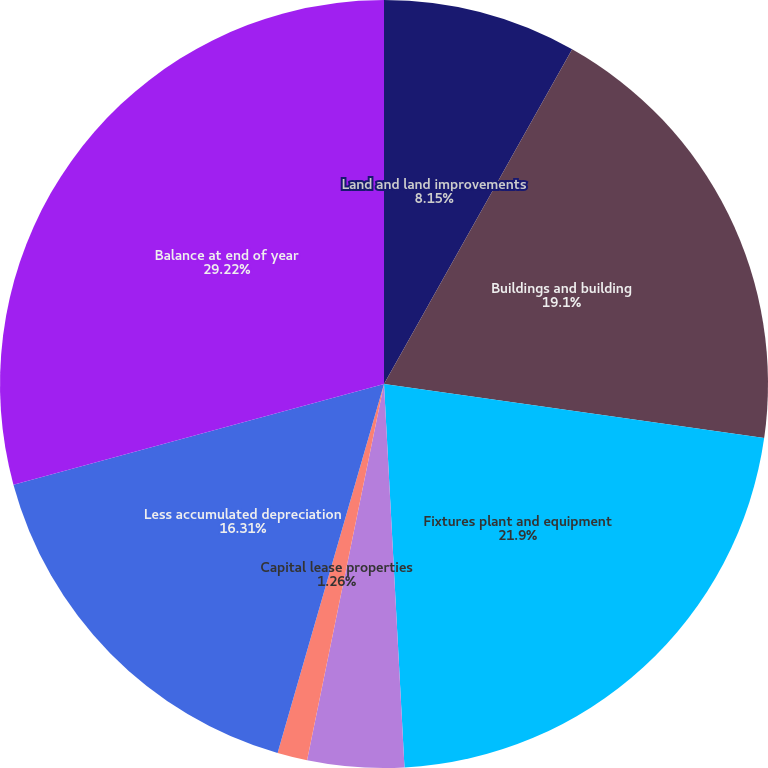Convert chart to OTSL. <chart><loc_0><loc_0><loc_500><loc_500><pie_chart><fcel>Land and land improvements<fcel>Buildings and building<fcel>Fixtures plant and equipment<fcel>Capitalized system development<fcel>Capital lease properties<fcel>Less accumulated depreciation<fcel>Balance at end of year<nl><fcel>8.15%<fcel>19.1%<fcel>21.9%<fcel>4.06%<fcel>1.26%<fcel>16.31%<fcel>29.22%<nl></chart> 